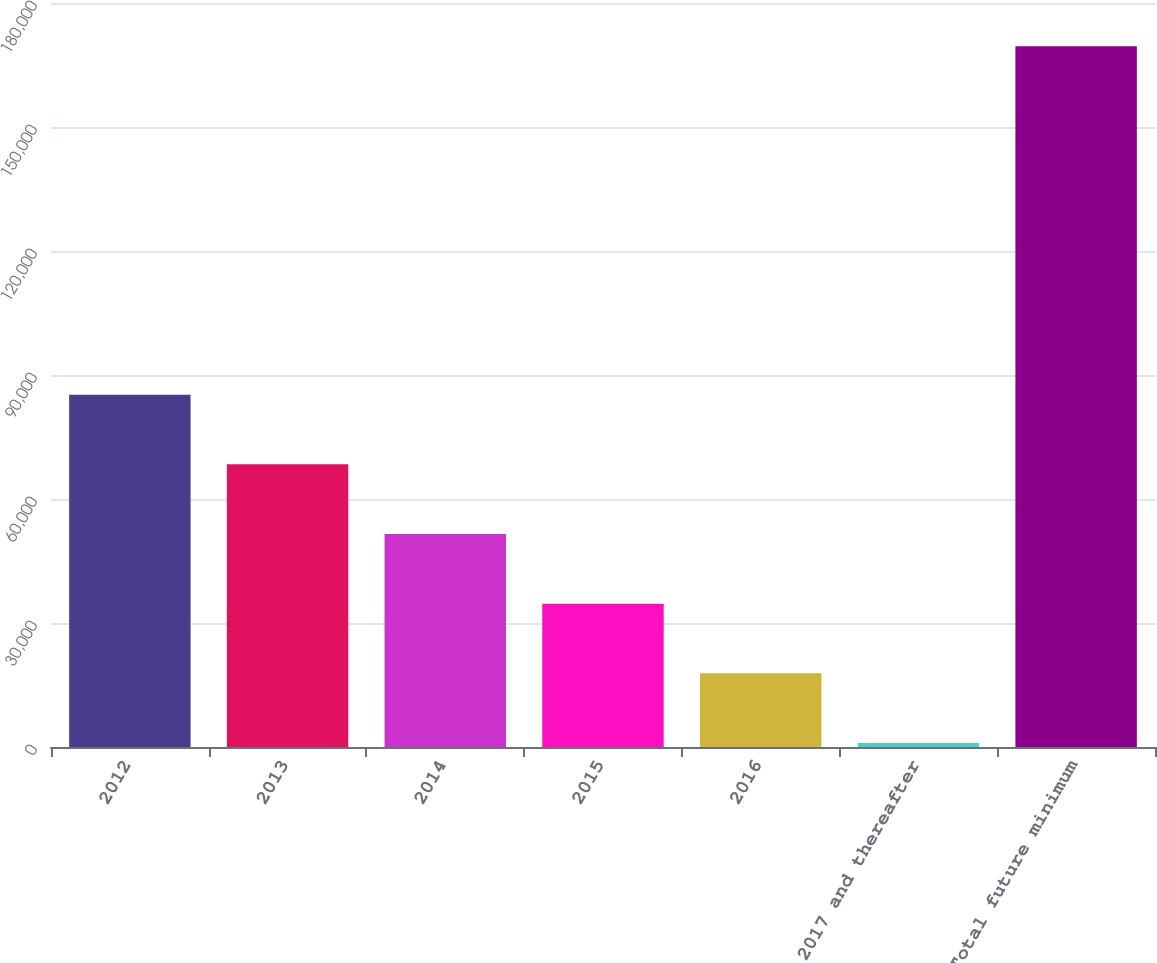Convert chart to OTSL. <chart><loc_0><loc_0><loc_500><loc_500><bar_chart><fcel>2012<fcel>2013<fcel>2014<fcel>2015<fcel>2016<fcel>2017 and thereafter<fcel>Total future minimum<nl><fcel>85240<fcel>68385.2<fcel>51530.4<fcel>34675.6<fcel>17820.8<fcel>966<fcel>169514<nl></chart> 